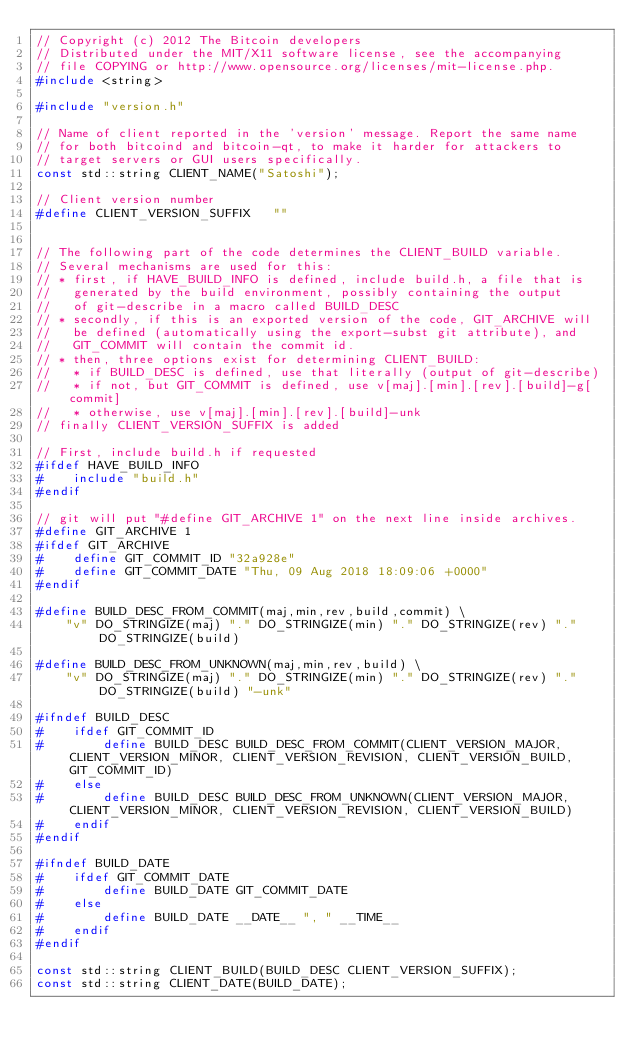<code> <loc_0><loc_0><loc_500><loc_500><_C++_>// Copyright (c) 2012 The Bitcoin developers
// Distributed under the MIT/X11 software license, see the accompanying
// file COPYING or http://www.opensource.org/licenses/mit-license.php.
#include <string>

#include "version.h"

// Name of client reported in the 'version' message. Report the same name
// for both bitcoind and bitcoin-qt, to make it harder for attackers to
// target servers or GUI users specifically.
const std::string CLIENT_NAME("Satoshi");

// Client version number
#define CLIENT_VERSION_SUFFIX   ""


// The following part of the code determines the CLIENT_BUILD variable.
// Several mechanisms are used for this:
// * first, if HAVE_BUILD_INFO is defined, include build.h, a file that is
//   generated by the build environment, possibly containing the output
//   of git-describe in a macro called BUILD_DESC
// * secondly, if this is an exported version of the code, GIT_ARCHIVE will
//   be defined (automatically using the export-subst git attribute), and
//   GIT_COMMIT will contain the commit id.
// * then, three options exist for determining CLIENT_BUILD:
//   * if BUILD_DESC is defined, use that literally (output of git-describe)
//   * if not, but GIT_COMMIT is defined, use v[maj].[min].[rev].[build]-g[commit]
//   * otherwise, use v[maj].[min].[rev].[build]-unk
// finally CLIENT_VERSION_SUFFIX is added

// First, include build.h if requested
#ifdef HAVE_BUILD_INFO
#    include "build.h"
#endif

// git will put "#define GIT_ARCHIVE 1" on the next line inside archives. 
#define GIT_ARCHIVE 1
#ifdef GIT_ARCHIVE
#    define GIT_COMMIT_ID "32a928e"
#    define GIT_COMMIT_DATE "Thu, 09 Aug 2018 18:09:06 +0000"
#endif

#define BUILD_DESC_FROM_COMMIT(maj,min,rev,build,commit) \
    "v" DO_STRINGIZE(maj) "." DO_STRINGIZE(min) "." DO_STRINGIZE(rev) "." DO_STRINGIZE(build) 

#define BUILD_DESC_FROM_UNKNOWN(maj,min,rev,build) \
    "v" DO_STRINGIZE(maj) "." DO_STRINGIZE(min) "." DO_STRINGIZE(rev) "." DO_STRINGIZE(build) "-unk"

#ifndef BUILD_DESC
#    ifdef GIT_COMMIT_ID
#        define BUILD_DESC BUILD_DESC_FROM_COMMIT(CLIENT_VERSION_MAJOR, CLIENT_VERSION_MINOR, CLIENT_VERSION_REVISION, CLIENT_VERSION_BUILD, GIT_COMMIT_ID)
#    else
#        define BUILD_DESC BUILD_DESC_FROM_UNKNOWN(CLIENT_VERSION_MAJOR, CLIENT_VERSION_MINOR, CLIENT_VERSION_REVISION, CLIENT_VERSION_BUILD)
#    endif
#endif

#ifndef BUILD_DATE
#    ifdef GIT_COMMIT_DATE
#        define BUILD_DATE GIT_COMMIT_DATE
#    else
#        define BUILD_DATE __DATE__ ", " __TIME__
#    endif
#endif

const std::string CLIENT_BUILD(BUILD_DESC CLIENT_VERSION_SUFFIX);
const std::string CLIENT_DATE(BUILD_DATE);
</code> 